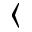<formula> <loc_0><loc_0><loc_500><loc_500>\langle</formula> 